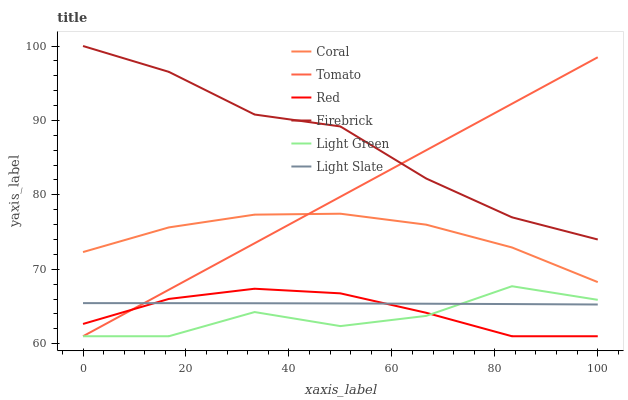Does Light Green have the minimum area under the curve?
Answer yes or no. Yes. Does Firebrick have the maximum area under the curve?
Answer yes or no. Yes. Does Light Slate have the minimum area under the curve?
Answer yes or no. No. Does Light Slate have the maximum area under the curve?
Answer yes or no. No. Is Tomato the smoothest?
Answer yes or no. Yes. Is Light Green the roughest?
Answer yes or no. Yes. Is Light Slate the smoothest?
Answer yes or no. No. Is Light Slate the roughest?
Answer yes or no. No. Does Tomato have the lowest value?
Answer yes or no. Yes. Does Light Slate have the lowest value?
Answer yes or no. No. Does Firebrick have the highest value?
Answer yes or no. Yes. Does Coral have the highest value?
Answer yes or no. No. Is Light Green less than Firebrick?
Answer yes or no. Yes. Is Firebrick greater than Coral?
Answer yes or no. Yes. Does Light Slate intersect Tomato?
Answer yes or no. Yes. Is Light Slate less than Tomato?
Answer yes or no. No. Is Light Slate greater than Tomato?
Answer yes or no. No. Does Light Green intersect Firebrick?
Answer yes or no. No. 